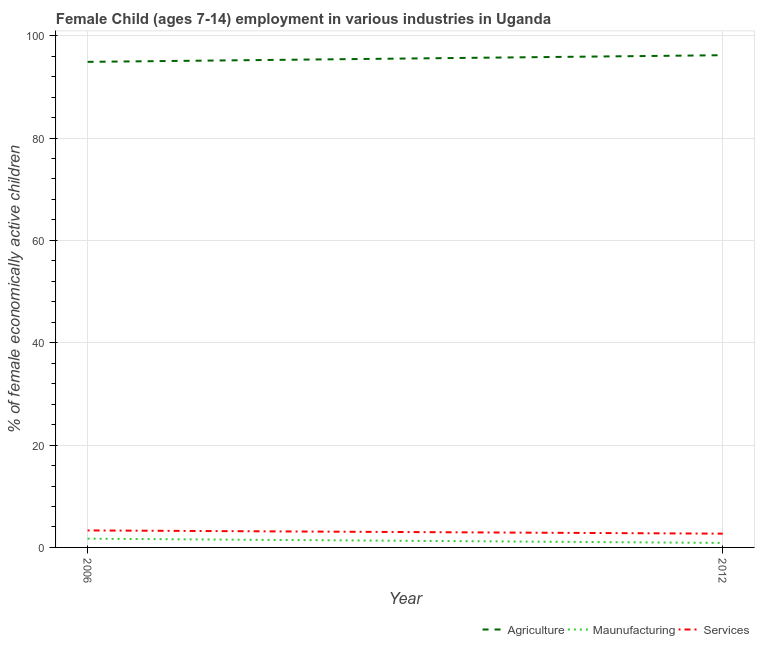Does the line corresponding to percentage of economically active children in manufacturing intersect with the line corresponding to percentage of economically active children in services?
Make the answer very short. No. What is the percentage of economically active children in agriculture in 2012?
Your answer should be very brief. 96.19. Across all years, what is the maximum percentage of economically active children in services?
Offer a very short reply. 3.32. Across all years, what is the minimum percentage of economically active children in agriculture?
Offer a very short reply. 94.89. In which year was the percentage of economically active children in manufacturing minimum?
Your answer should be compact. 2012. What is the total percentage of economically active children in agriculture in the graph?
Your answer should be compact. 191.08. What is the difference between the percentage of economically active children in services in 2006 and that in 2012?
Your response must be concise. 0.63. What is the difference between the percentage of economically active children in manufacturing in 2012 and the percentage of economically active children in services in 2006?
Give a very brief answer. -2.44. What is the average percentage of economically active children in agriculture per year?
Your response must be concise. 95.54. In the year 2012, what is the difference between the percentage of economically active children in agriculture and percentage of economically active children in manufacturing?
Ensure brevity in your answer.  95.31. What is the ratio of the percentage of economically active children in agriculture in 2006 to that in 2012?
Make the answer very short. 0.99. Is the percentage of economically active children in services in 2006 less than that in 2012?
Your answer should be very brief. No. In how many years, is the percentage of economically active children in manufacturing greater than the average percentage of economically active children in manufacturing taken over all years?
Offer a very short reply. 1. How many years are there in the graph?
Make the answer very short. 2. What is the difference between two consecutive major ticks on the Y-axis?
Keep it short and to the point. 20. Does the graph contain any zero values?
Give a very brief answer. No. Does the graph contain grids?
Provide a short and direct response. Yes. What is the title of the graph?
Your answer should be compact. Female Child (ages 7-14) employment in various industries in Uganda. What is the label or title of the Y-axis?
Offer a terse response. % of female economically active children. What is the % of female economically active children in Agriculture in 2006?
Provide a short and direct response. 94.89. What is the % of female economically active children of Maunufacturing in 2006?
Your answer should be compact. 1.71. What is the % of female economically active children of Services in 2006?
Keep it short and to the point. 3.32. What is the % of female economically active children in Agriculture in 2012?
Provide a succinct answer. 96.19. What is the % of female economically active children in Maunufacturing in 2012?
Give a very brief answer. 0.88. What is the % of female economically active children of Services in 2012?
Your answer should be compact. 2.69. Across all years, what is the maximum % of female economically active children in Agriculture?
Your answer should be compact. 96.19. Across all years, what is the maximum % of female economically active children of Maunufacturing?
Make the answer very short. 1.71. Across all years, what is the maximum % of female economically active children in Services?
Your answer should be compact. 3.32. Across all years, what is the minimum % of female economically active children of Agriculture?
Your answer should be compact. 94.89. Across all years, what is the minimum % of female economically active children in Services?
Provide a succinct answer. 2.69. What is the total % of female economically active children of Agriculture in the graph?
Your answer should be very brief. 191.08. What is the total % of female economically active children in Maunufacturing in the graph?
Provide a succinct answer. 2.59. What is the total % of female economically active children of Services in the graph?
Your response must be concise. 6.01. What is the difference between the % of female economically active children in Maunufacturing in 2006 and that in 2012?
Your response must be concise. 0.83. What is the difference between the % of female economically active children in Services in 2006 and that in 2012?
Your answer should be compact. 0.63. What is the difference between the % of female economically active children of Agriculture in 2006 and the % of female economically active children of Maunufacturing in 2012?
Keep it short and to the point. 94.01. What is the difference between the % of female economically active children in Agriculture in 2006 and the % of female economically active children in Services in 2012?
Your response must be concise. 92.2. What is the difference between the % of female economically active children in Maunufacturing in 2006 and the % of female economically active children in Services in 2012?
Give a very brief answer. -0.98. What is the average % of female economically active children of Agriculture per year?
Give a very brief answer. 95.54. What is the average % of female economically active children of Maunufacturing per year?
Give a very brief answer. 1.29. What is the average % of female economically active children in Services per year?
Keep it short and to the point. 3. In the year 2006, what is the difference between the % of female economically active children in Agriculture and % of female economically active children in Maunufacturing?
Your response must be concise. 93.18. In the year 2006, what is the difference between the % of female economically active children of Agriculture and % of female economically active children of Services?
Make the answer very short. 91.57. In the year 2006, what is the difference between the % of female economically active children in Maunufacturing and % of female economically active children in Services?
Your response must be concise. -1.61. In the year 2012, what is the difference between the % of female economically active children in Agriculture and % of female economically active children in Maunufacturing?
Provide a succinct answer. 95.31. In the year 2012, what is the difference between the % of female economically active children of Agriculture and % of female economically active children of Services?
Provide a short and direct response. 93.5. In the year 2012, what is the difference between the % of female economically active children of Maunufacturing and % of female economically active children of Services?
Make the answer very short. -1.81. What is the ratio of the % of female economically active children in Agriculture in 2006 to that in 2012?
Offer a terse response. 0.99. What is the ratio of the % of female economically active children of Maunufacturing in 2006 to that in 2012?
Your answer should be very brief. 1.94. What is the ratio of the % of female economically active children in Services in 2006 to that in 2012?
Offer a terse response. 1.23. What is the difference between the highest and the second highest % of female economically active children in Maunufacturing?
Your answer should be compact. 0.83. What is the difference between the highest and the second highest % of female economically active children in Services?
Offer a terse response. 0.63. What is the difference between the highest and the lowest % of female economically active children in Agriculture?
Keep it short and to the point. 1.3. What is the difference between the highest and the lowest % of female economically active children of Maunufacturing?
Your answer should be compact. 0.83. What is the difference between the highest and the lowest % of female economically active children of Services?
Offer a very short reply. 0.63. 